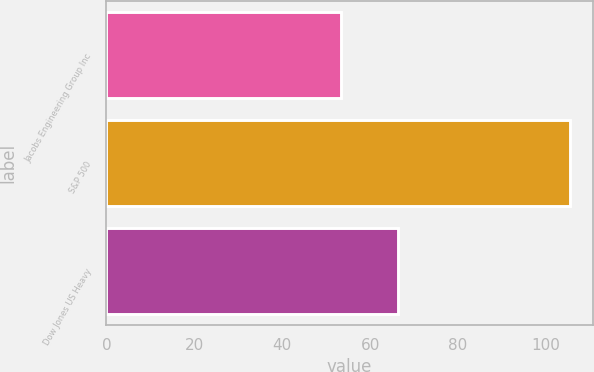Convert chart to OTSL. <chart><loc_0><loc_0><loc_500><loc_500><bar_chart><fcel>Jacobs Engineering Group Inc<fcel>S&P 500<fcel>Dow Jones US Heavy<nl><fcel>53.49<fcel>105.37<fcel>66.25<nl></chart> 